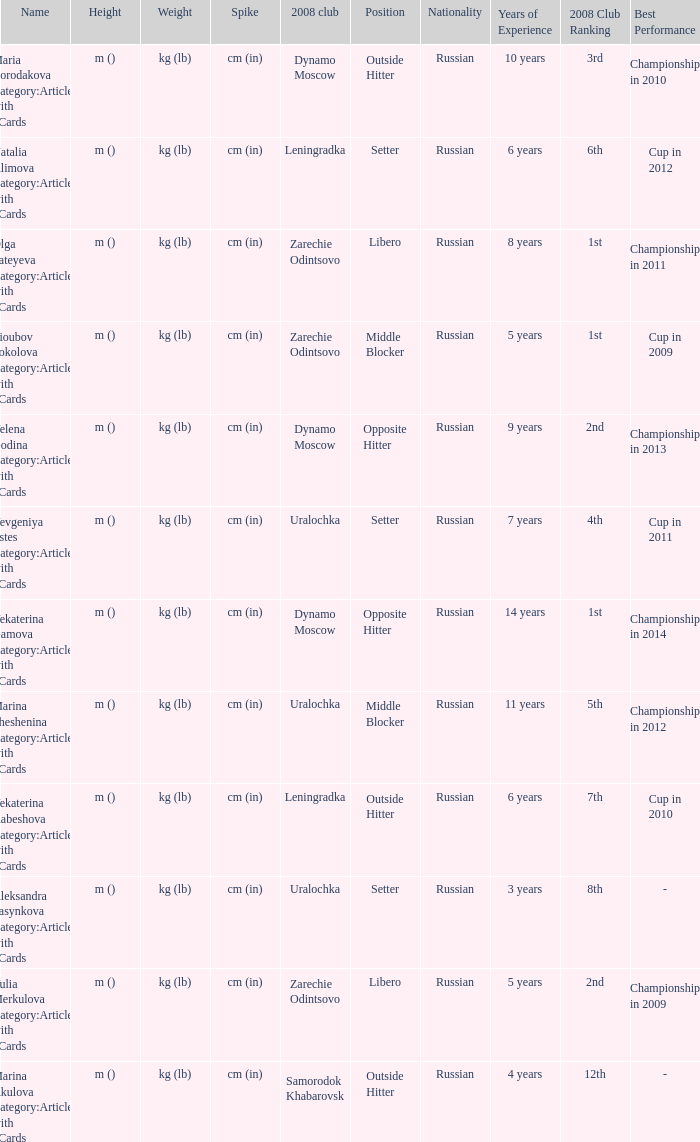What is the title when the 2008 club is uralochka? Yevgeniya Estes Category:Articles with hCards, Marina Sheshenina Category:Articles with hCards, Aleksandra Pasynkova Category:Articles with hCards. 